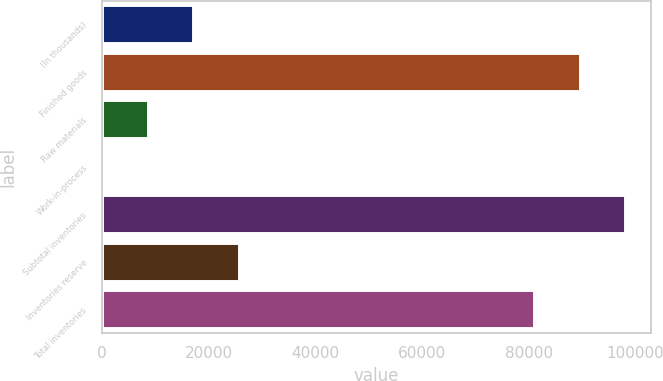Convert chart. <chart><loc_0><loc_0><loc_500><loc_500><bar_chart><fcel>(In thousands)<fcel>Finished goods<fcel>Raw materials<fcel>Work-in-process<fcel>Subtotal inventories<fcel>Inventories reserve<fcel>Total inventories<nl><fcel>17120.8<fcel>89524.9<fcel>8626.9<fcel>133<fcel>98018.8<fcel>25614.7<fcel>81031<nl></chart> 